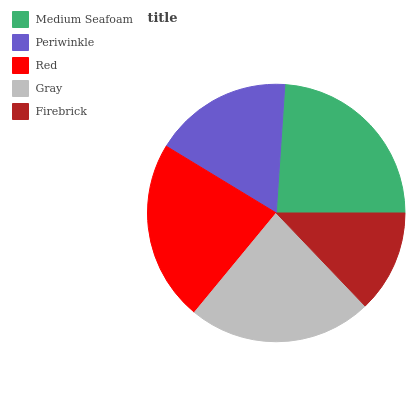Is Firebrick the minimum?
Answer yes or no. Yes. Is Medium Seafoam the maximum?
Answer yes or no. Yes. Is Periwinkle the minimum?
Answer yes or no. No. Is Periwinkle the maximum?
Answer yes or no. No. Is Medium Seafoam greater than Periwinkle?
Answer yes or no. Yes. Is Periwinkle less than Medium Seafoam?
Answer yes or no. Yes. Is Periwinkle greater than Medium Seafoam?
Answer yes or no. No. Is Medium Seafoam less than Periwinkle?
Answer yes or no. No. Is Red the high median?
Answer yes or no. Yes. Is Red the low median?
Answer yes or no. Yes. Is Periwinkle the high median?
Answer yes or no. No. Is Periwinkle the low median?
Answer yes or no. No. 